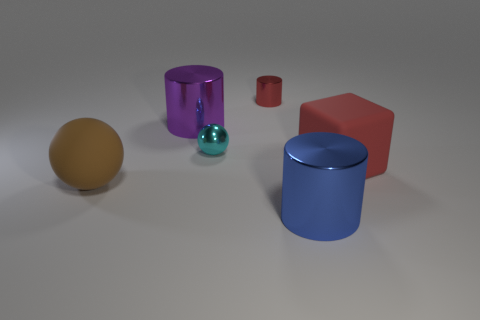What material is the small thing that is the same color as the big matte cube?
Give a very brief answer. Metal. What number of big rubber things are there?
Ensure brevity in your answer.  2. What number of things are both on the left side of the red cube and to the right of the big brown rubber ball?
Provide a succinct answer. 4. What is the material of the large ball?
Keep it short and to the point. Rubber. Are any small green metal things visible?
Your answer should be compact. No. There is a cylinder right of the tiny red cylinder; what color is it?
Your response must be concise. Blue. There is a thing that is right of the big shiny thing in front of the red cube; how many big metallic things are behind it?
Provide a short and direct response. 1. There is a thing that is both in front of the large red object and right of the rubber sphere; what material is it?
Your answer should be compact. Metal. Are the small ball and the big cylinder that is to the left of the large blue metallic object made of the same material?
Provide a succinct answer. Yes. Are there more red things behind the cube than large spheres that are to the right of the small red thing?
Your answer should be very brief. Yes. 